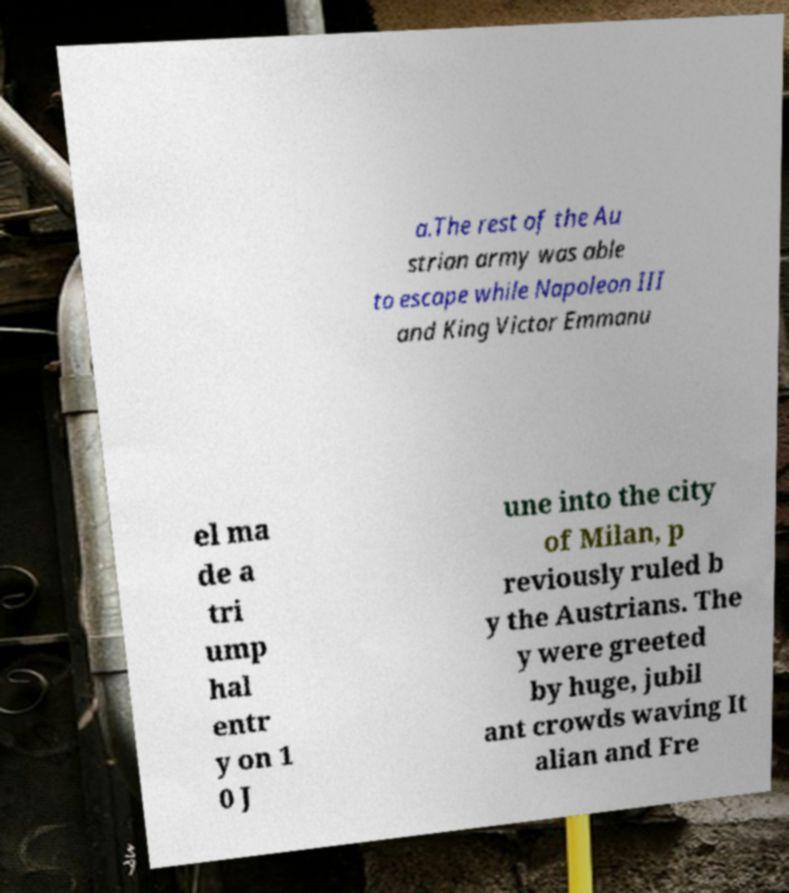Could you extract and type out the text from this image? a.The rest of the Au strian army was able to escape while Napoleon III and King Victor Emmanu el ma de a tri ump hal entr y on 1 0 J une into the city of Milan, p reviously ruled b y the Austrians. The y were greeted by huge, jubil ant crowds waving It alian and Fre 